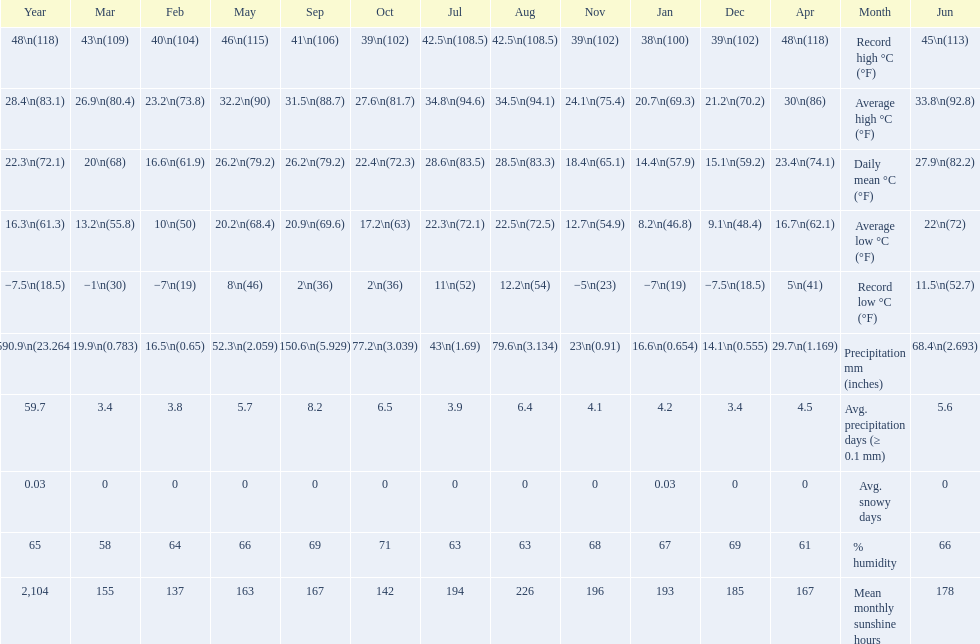Did march or april have more precipitation? April. 